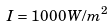<formula> <loc_0><loc_0><loc_500><loc_500>I = 1 0 0 0 \, W / m ^ { 2 }</formula> 